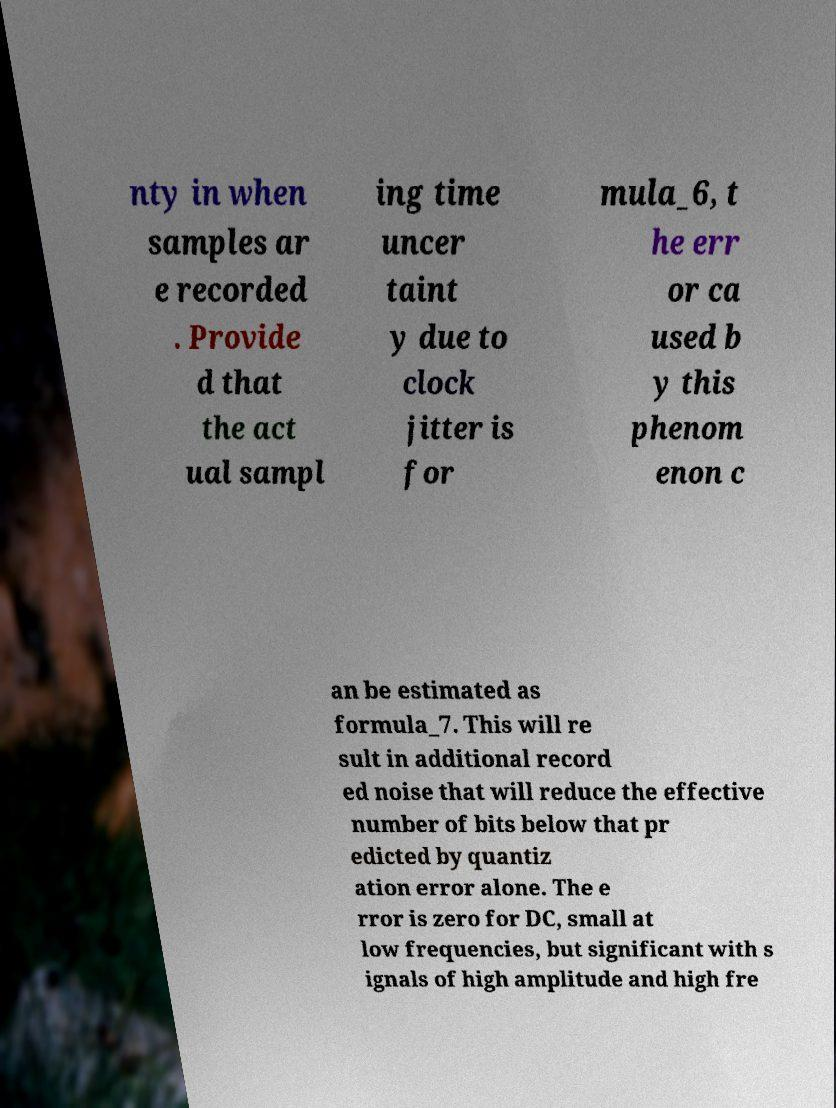Can you read and provide the text displayed in the image?This photo seems to have some interesting text. Can you extract and type it out for me? nty in when samples ar e recorded . Provide d that the act ual sampl ing time uncer taint y due to clock jitter is for mula_6, t he err or ca used b y this phenom enon c an be estimated as formula_7. This will re sult in additional record ed noise that will reduce the effective number of bits below that pr edicted by quantiz ation error alone. The e rror is zero for DC, small at low frequencies, but significant with s ignals of high amplitude and high fre 